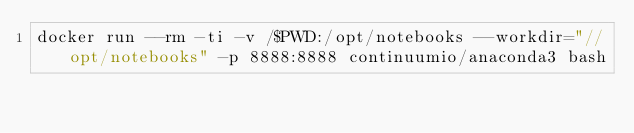Convert code to text. <code><loc_0><loc_0><loc_500><loc_500><_Bash_>docker run --rm -ti -v /$PWD:/opt/notebooks --workdir="//opt/notebooks" -p 8888:8888 continuumio/anaconda3 bash</code> 